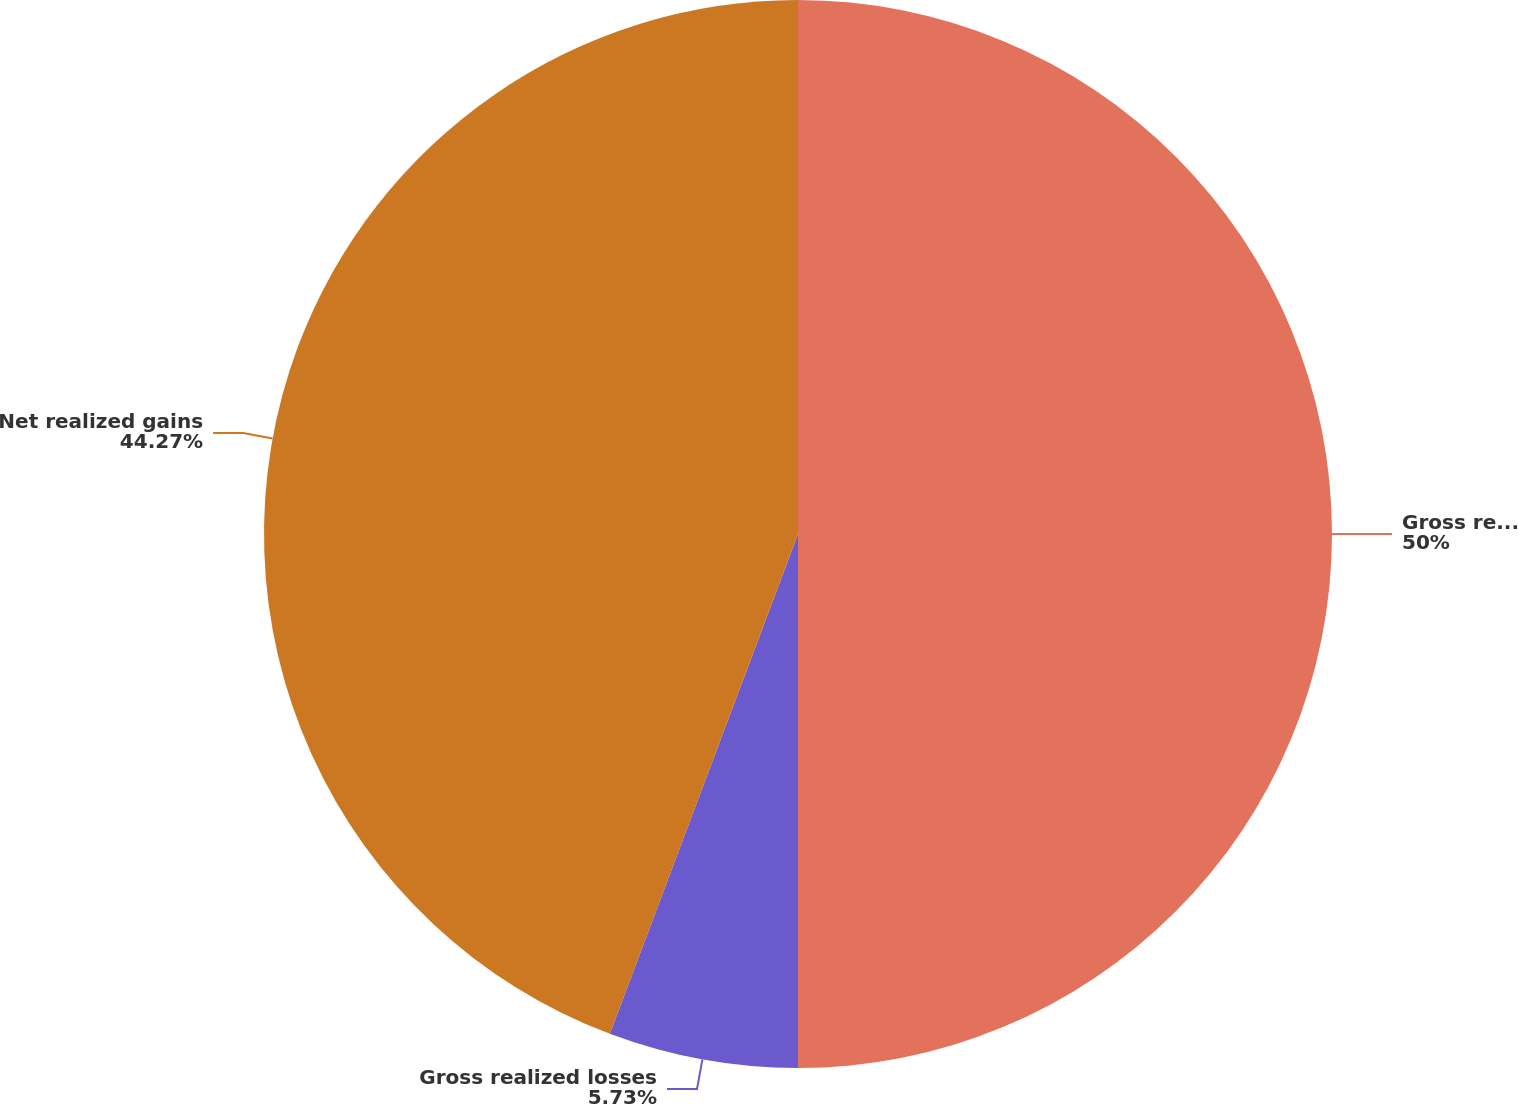Convert chart to OTSL. <chart><loc_0><loc_0><loc_500><loc_500><pie_chart><fcel>Gross realized gains<fcel>Gross realized losses<fcel>Net realized gains<nl><fcel>50.0%<fcel>5.73%<fcel>44.27%<nl></chart> 